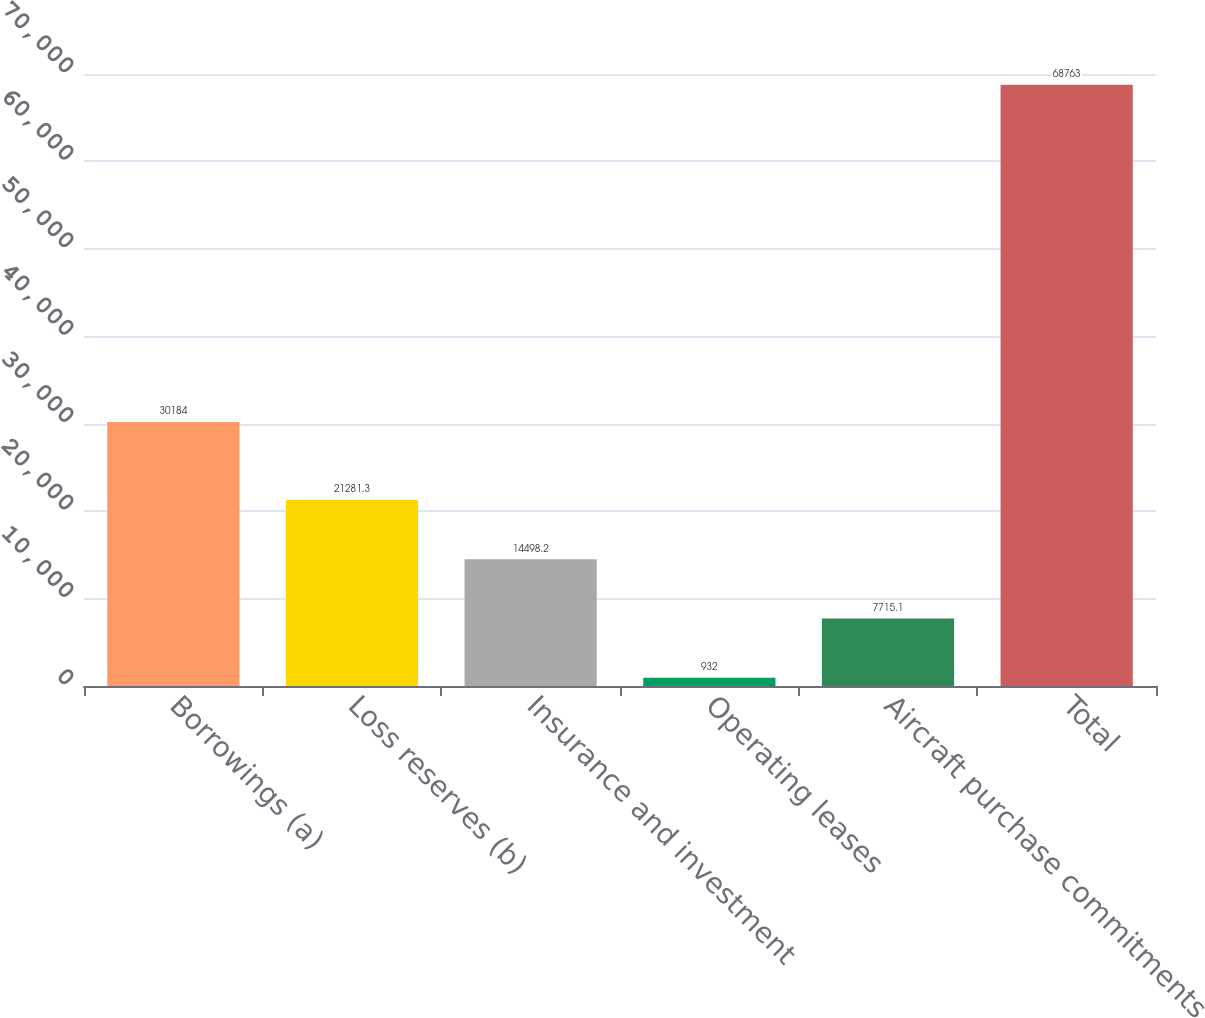<chart> <loc_0><loc_0><loc_500><loc_500><bar_chart><fcel>Borrowings (a)<fcel>Loss reserves (b)<fcel>Insurance and investment<fcel>Operating leases<fcel>Aircraft purchase commitments<fcel>Total<nl><fcel>30184<fcel>21281.3<fcel>14498.2<fcel>932<fcel>7715.1<fcel>68763<nl></chart> 